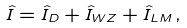<formula> <loc_0><loc_0><loc_500><loc_500>\hat { I } = \hat { I } _ { D } + \hat { I } _ { W Z } + \hat { I } _ { L M } \, ,</formula> 